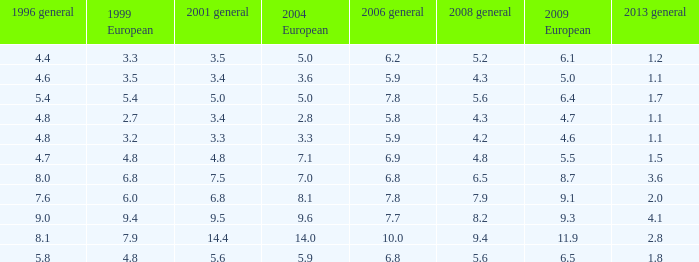Could you help me parse every detail presented in this table? {'header': ['1996 general', '1999 European', '2001 general', '2004 European', '2006 general', '2008 general', '2009 European', '2013 general'], 'rows': [['4.4', '3.3', '3.5', '5.0', '6.2', '5.2', '6.1', '1.2'], ['4.6', '3.5', '3.4', '3.6', '5.9', '4.3', '5.0', '1.1'], ['5.4', '5.4', '5.0', '5.0', '7.8', '5.6', '6.4', '1.7'], ['4.8', '2.7', '3.4', '2.8', '5.8', '4.3', '4.7', '1.1'], ['4.8', '3.2', '3.3', '3.3', '5.9', '4.2', '4.6', '1.1'], ['4.7', '4.8', '4.8', '7.1', '6.9', '4.8', '5.5', '1.5'], ['8.0', '6.8', '7.5', '7.0', '6.8', '6.5', '8.7', '3.6'], ['7.6', '6.0', '6.8', '8.1', '7.8', '7.9', '9.1', '2.0'], ['9.0', '9.4', '9.5', '9.6', '7.7', '8.2', '9.3', '4.1'], ['8.1', '7.9', '14.4', '14.0', '10.0', '9.4', '11.9', '2.8'], ['5.8', '4.8', '5.6', '5.9', '6.8', '5.6', '6.5', '1.8']]} What is the highest value for general 2008 when there is less than 5.5 in European 2009, more than 5.8 in general 2006, more than 3.3 in general 2001, and less than 3.6 for 2004 European? None. 